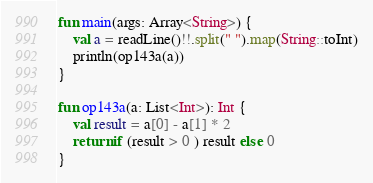<code> <loc_0><loc_0><loc_500><loc_500><_Kotlin_>fun main(args: Array<String>) {
    val a = readLine()!!.split(" ").map(String::toInt)
    println(op143a(a))
}

fun op143a(a: List<Int>): Int {
    val result = a[0] - a[1] * 2
    return if (result > 0 ) result else 0
}
</code> 